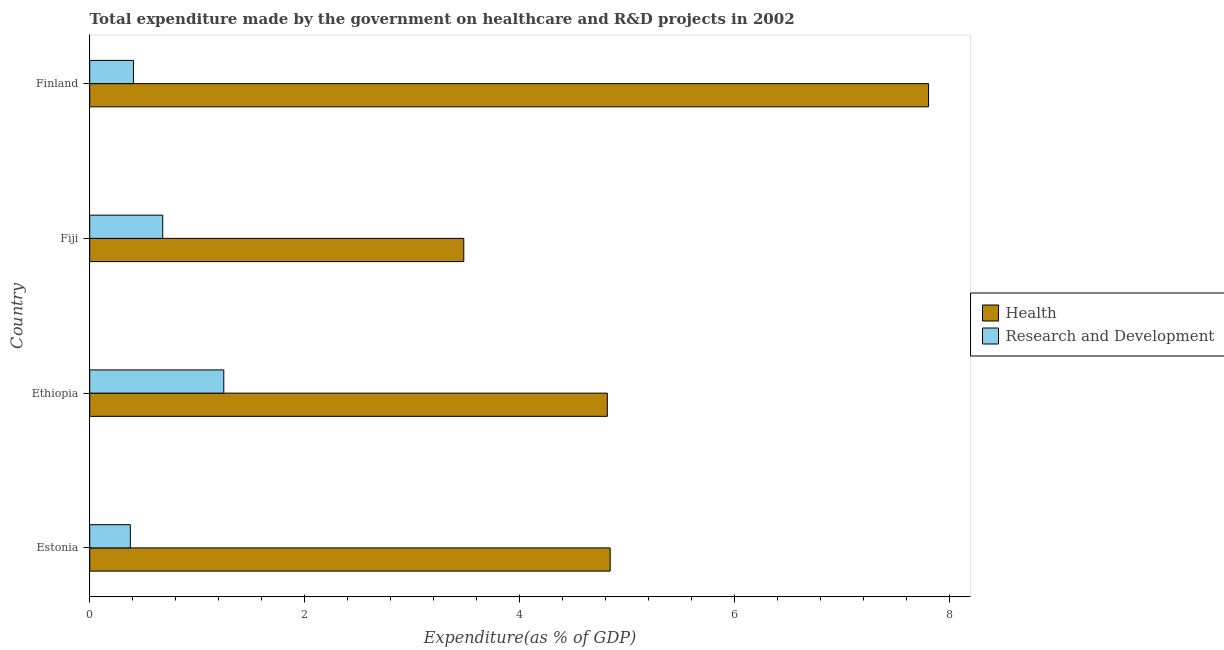Are the number of bars per tick equal to the number of legend labels?
Make the answer very short. Yes. What is the expenditure in healthcare in Fiji?
Make the answer very short. 3.48. Across all countries, what is the maximum expenditure in healthcare?
Make the answer very short. 7.81. Across all countries, what is the minimum expenditure in r&d?
Offer a very short reply. 0.38. In which country was the expenditure in healthcare maximum?
Offer a very short reply. Finland. In which country was the expenditure in r&d minimum?
Ensure brevity in your answer.  Estonia. What is the total expenditure in r&d in the graph?
Offer a very short reply. 2.71. What is the difference between the expenditure in healthcare in Ethiopia and that in Fiji?
Give a very brief answer. 1.34. What is the difference between the expenditure in healthcare in Fiji and the expenditure in r&d in Ethiopia?
Offer a terse response. 2.23. What is the average expenditure in r&d per country?
Give a very brief answer. 0.68. What is the difference between the expenditure in healthcare and expenditure in r&d in Ethiopia?
Your answer should be compact. 3.57. What is the ratio of the expenditure in healthcare in Ethiopia to that in Fiji?
Provide a short and direct response. 1.38. What is the difference between the highest and the second highest expenditure in r&d?
Offer a very short reply. 0.57. What is the difference between the highest and the lowest expenditure in healthcare?
Keep it short and to the point. 4.33. In how many countries, is the expenditure in r&d greater than the average expenditure in r&d taken over all countries?
Keep it short and to the point. 2. Is the sum of the expenditure in r&d in Estonia and Ethiopia greater than the maximum expenditure in healthcare across all countries?
Make the answer very short. No. What does the 2nd bar from the top in Ethiopia represents?
Your answer should be very brief. Health. What does the 1st bar from the bottom in Fiji represents?
Make the answer very short. Health. How many bars are there?
Provide a succinct answer. 8. How many countries are there in the graph?
Give a very brief answer. 4. Are the values on the major ticks of X-axis written in scientific E-notation?
Offer a terse response. No. Does the graph contain grids?
Your answer should be very brief. No. How are the legend labels stacked?
Your response must be concise. Vertical. What is the title of the graph?
Keep it short and to the point. Total expenditure made by the government on healthcare and R&D projects in 2002. What is the label or title of the X-axis?
Provide a succinct answer. Expenditure(as % of GDP). What is the label or title of the Y-axis?
Your answer should be compact. Country. What is the Expenditure(as % of GDP) in Health in Estonia?
Ensure brevity in your answer.  4.84. What is the Expenditure(as % of GDP) in Research and Development in Estonia?
Keep it short and to the point. 0.38. What is the Expenditure(as % of GDP) in Health in Ethiopia?
Make the answer very short. 4.82. What is the Expenditure(as % of GDP) in Research and Development in Ethiopia?
Your answer should be compact. 1.25. What is the Expenditure(as % of GDP) of Health in Fiji?
Provide a short and direct response. 3.48. What is the Expenditure(as % of GDP) of Research and Development in Fiji?
Your response must be concise. 0.68. What is the Expenditure(as % of GDP) of Health in Finland?
Keep it short and to the point. 7.81. What is the Expenditure(as % of GDP) in Research and Development in Finland?
Your response must be concise. 0.41. Across all countries, what is the maximum Expenditure(as % of GDP) of Health?
Your answer should be very brief. 7.81. Across all countries, what is the maximum Expenditure(as % of GDP) in Research and Development?
Your response must be concise. 1.25. Across all countries, what is the minimum Expenditure(as % of GDP) of Health?
Offer a very short reply. 3.48. Across all countries, what is the minimum Expenditure(as % of GDP) of Research and Development?
Offer a very short reply. 0.38. What is the total Expenditure(as % of GDP) of Health in the graph?
Offer a very short reply. 20.95. What is the total Expenditure(as % of GDP) in Research and Development in the graph?
Make the answer very short. 2.71. What is the difference between the Expenditure(as % of GDP) of Health in Estonia and that in Ethiopia?
Keep it short and to the point. 0.03. What is the difference between the Expenditure(as % of GDP) in Research and Development in Estonia and that in Ethiopia?
Your response must be concise. -0.87. What is the difference between the Expenditure(as % of GDP) in Health in Estonia and that in Fiji?
Offer a very short reply. 1.36. What is the difference between the Expenditure(as % of GDP) in Research and Development in Estonia and that in Fiji?
Ensure brevity in your answer.  -0.3. What is the difference between the Expenditure(as % of GDP) in Health in Estonia and that in Finland?
Provide a short and direct response. -2.96. What is the difference between the Expenditure(as % of GDP) of Research and Development in Estonia and that in Finland?
Offer a very short reply. -0.03. What is the difference between the Expenditure(as % of GDP) in Health in Ethiopia and that in Fiji?
Provide a succinct answer. 1.34. What is the difference between the Expenditure(as % of GDP) in Research and Development in Ethiopia and that in Fiji?
Make the answer very short. 0.57. What is the difference between the Expenditure(as % of GDP) in Health in Ethiopia and that in Finland?
Offer a terse response. -2.99. What is the difference between the Expenditure(as % of GDP) in Research and Development in Ethiopia and that in Finland?
Offer a very short reply. 0.84. What is the difference between the Expenditure(as % of GDP) of Health in Fiji and that in Finland?
Offer a terse response. -4.33. What is the difference between the Expenditure(as % of GDP) of Research and Development in Fiji and that in Finland?
Offer a terse response. 0.27. What is the difference between the Expenditure(as % of GDP) in Health in Estonia and the Expenditure(as % of GDP) in Research and Development in Ethiopia?
Offer a terse response. 3.6. What is the difference between the Expenditure(as % of GDP) of Health in Estonia and the Expenditure(as % of GDP) of Research and Development in Fiji?
Keep it short and to the point. 4.16. What is the difference between the Expenditure(as % of GDP) of Health in Estonia and the Expenditure(as % of GDP) of Research and Development in Finland?
Offer a terse response. 4.44. What is the difference between the Expenditure(as % of GDP) in Health in Ethiopia and the Expenditure(as % of GDP) in Research and Development in Fiji?
Keep it short and to the point. 4.14. What is the difference between the Expenditure(as % of GDP) in Health in Ethiopia and the Expenditure(as % of GDP) in Research and Development in Finland?
Keep it short and to the point. 4.41. What is the difference between the Expenditure(as % of GDP) in Health in Fiji and the Expenditure(as % of GDP) in Research and Development in Finland?
Give a very brief answer. 3.07. What is the average Expenditure(as % of GDP) in Health per country?
Your answer should be very brief. 5.24. What is the average Expenditure(as % of GDP) of Research and Development per country?
Your answer should be compact. 0.68. What is the difference between the Expenditure(as % of GDP) of Health and Expenditure(as % of GDP) of Research and Development in Estonia?
Your answer should be very brief. 4.47. What is the difference between the Expenditure(as % of GDP) of Health and Expenditure(as % of GDP) of Research and Development in Ethiopia?
Your answer should be very brief. 3.57. What is the difference between the Expenditure(as % of GDP) of Health and Expenditure(as % of GDP) of Research and Development in Fiji?
Offer a very short reply. 2.8. What is the difference between the Expenditure(as % of GDP) in Health and Expenditure(as % of GDP) in Research and Development in Finland?
Your answer should be compact. 7.4. What is the ratio of the Expenditure(as % of GDP) in Research and Development in Estonia to that in Ethiopia?
Make the answer very short. 0.3. What is the ratio of the Expenditure(as % of GDP) of Health in Estonia to that in Fiji?
Make the answer very short. 1.39. What is the ratio of the Expenditure(as % of GDP) of Research and Development in Estonia to that in Fiji?
Your answer should be compact. 0.56. What is the ratio of the Expenditure(as % of GDP) of Health in Estonia to that in Finland?
Keep it short and to the point. 0.62. What is the ratio of the Expenditure(as % of GDP) of Research and Development in Estonia to that in Finland?
Offer a terse response. 0.93. What is the ratio of the Expenditure(as % of GDP) in Health in Ethiopia to that in Fiji?
Offer a very short reply. 1.38. What is the ratio of the Expenditure(as % of GDP) in Research and Development in Ethiopia to that in Fiji?
Ensure brevity in your answer.  1.84. What is the ratio of the Expenditure(as % of GDP) of Health in Ethiopia to that in Finland?
Ensure brevity in your answer.  0.62. What is the ratio of the Expenditure(as % of GDP) in Research and Development in Ethiopia to that in Finland?
Keep it short and to the point. 3.07. What is the ratio of the Expenditure(as % of GDP) of Health in Fiji to that in Finland?
Provide a short and direct response. 0.45. What is the ratio of the Expenditure(as % of GDP) in Research and Development in Fiji to that in Finland?
Keep it short and to the point. 1.67. What is the difference between the highest and the second highest Expenditure(as % of GDP) in Health?
Offer a terse response. 2.96. What is the difference between the highest and the second highest Expenditure(as % of GDP) in Research and Development?
Your answer should be compact. 0.57. What is the difference between the highest and the lowest Expenditure(as % of GDP) of Health?
Your response must be concise. 4.33. What is the difference between the highest and the lowest Expenditure(as % of GDP) in Research and Development?
Give a very brief answer. 0.87. 